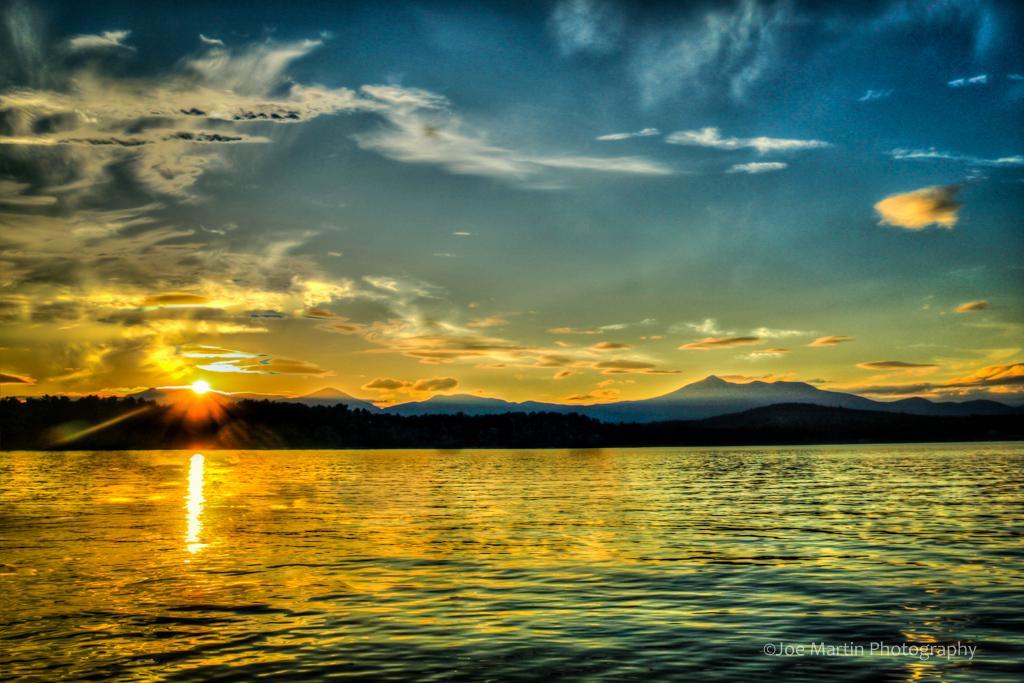Describe this image in one or two sentences. On the bottom right, there is a watermark. At the bottom of this image, there is water. In the background, there are mountains and there are clouds and a sun in the sky. 